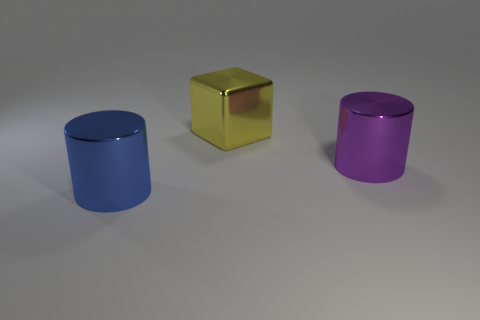Are there any other things that have the same material as the large blue cylinder?
Your response must be concise. Yes. There is a large cylinder on the right side of the metallic object behind the large metal cylinder that is behind the big blue metallic object; what is its color?
Ensure brevity in your answer.  Purple. Do the large metallic object that is in front of the big purple metal cylinder and the purple metal object have the same shape?
Your answer should be compact. Yes. How many large blue metallic cylinders are there?
Keep it short and to the point. 1. What number of green blocks are the same size as the yellow metal object?
Ensure brevity in your answer.  0. What material is the blue cylinder?
Keep it short and to the point. Metal. There is a large block; is it the same color as the cylinder behind the blue thing?
Your response must be concise. No. There is a metal thing that is both in front of the big yellow block and to the left of the big purple object; what is its size?
Give a very brief answer. Large. What shape is the yellow object that is the same material as the blue object?
Your answer should be compact. Cube. Is the material of the big blue thing the same as the big object behind the big purple thing?
Your answer should be very brief. Yes. 